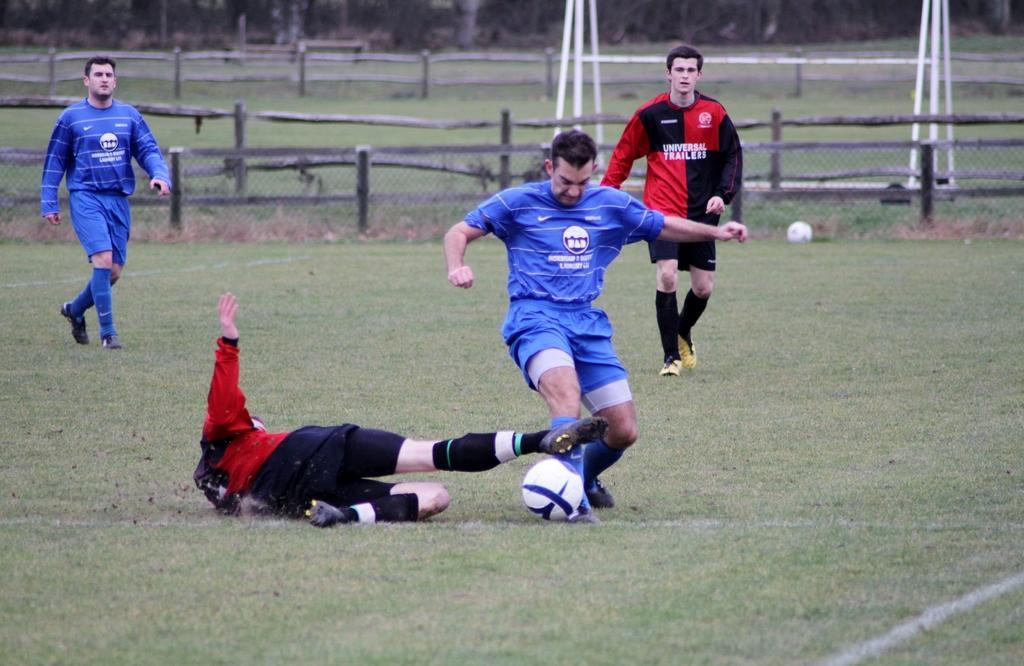Could you give a brief overview of what you see in this image? In this picture we can see four men playing in a playground. This is a ball. Here we can see fence with branches. This is a stand with net. 